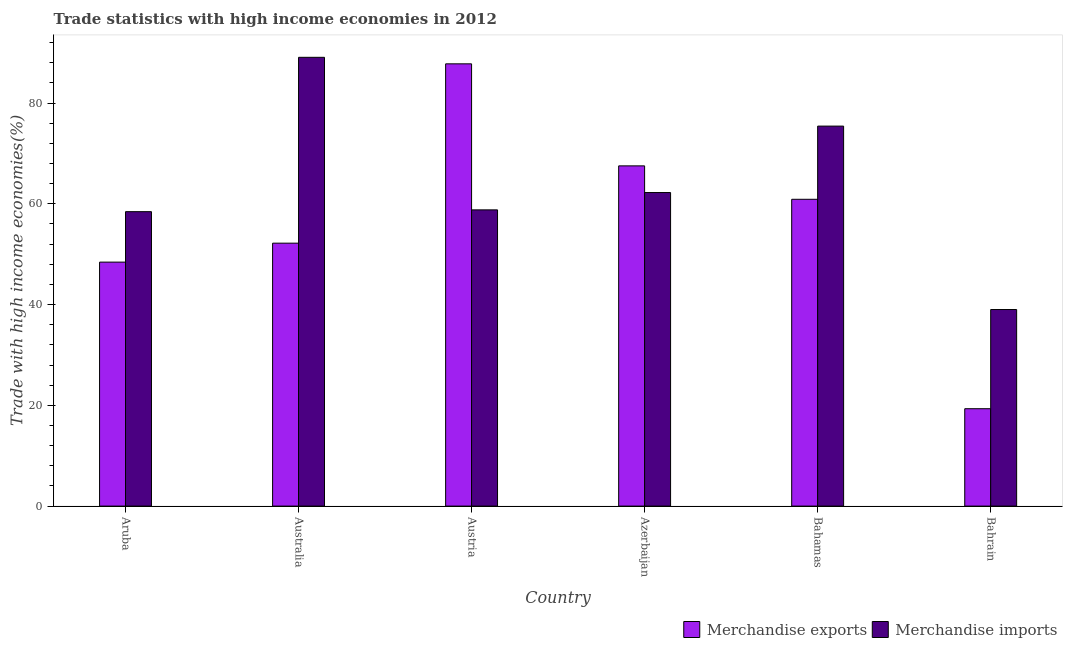Are the number of bars per tick equal to the number of legend labels?
Keep it short and to the point. Yes. How many bars are there on the 6th tick from the left?
Make the answer very short. 2. What is the label of the 6th group of bars from the left?
Your response must be concise. Bahrain. What is the merchandise imports in Aruba?
Give a very brief answer. 58.44. Across all countries, what is the maximum merchandise imports?
Give a very brief answer. 89.08. Across all countries, what is the minimum merchandise exports?
Offer a very short reply. 19.33. In which country was the merchandise exports minimum?
Offer a terse response. Bahrain. What is the total merchandise imports in the graph?
Offer a very short reply. 382.99. What is the difference between the merchandise imports in Austria and that in Bahrain?
Your answer should be very brief. 19.78. What is the difference between the merchandise exports in Australia and the merchandise imports in Bahamas?
Your answer should be compact. -23.24. What is the average merchandise imports per country?
Give a very brief answer. 63.83. What is the difference between the merchandise exports and merchandise imports in Bahrain?
Offer a very short reply. -19.69. What is the ratio of the merchandise imports in Aruba to that in Australia?
Provide a short and direct response. 0.66. Is the merchandise imports in Azerbaijan less than that in Bahrain?
Give a very brief answer. No. What is the difference between the highest and the second highest merchandise exports?
Your answer should be compact. 20.25. What is the difference between the highest and the lowest merchandise exports?
Provide a short and direct response. 68.45. Is the sum of the merchandise exports in Aruba and Australia greater than the maximum merchandise imports across all countries?
Your answer should be very brief. Yes. What does the 2nd bar from the left in Azerbaijan represents?
Provide a short and direct response. Merchandise imports. What does the 2nd bar from the right in Bahamas represents?
Offer a terse response. Merchandise exports. How many bars are there?
Ensure brevity in your answer.  12. How many countries are there in the graph?
Give a very brief answer. 6. Does the graph contain any zero values?
Offer a terse response. No. Where does the legend appear in the graph?
Your response must be concise. Bottom right. How many legend labels are there?
Your response must be concise. 2. How are the legend labels stacked?
Your answer should be very brief. Horizontal. What is the title of the graph?
Your response must be concise. Trade statistics with high income economies in 2012. Does "Technicians" appear as one of the legend labels in the graph?
Make the answer very short. No. What is the label or title of the Y-axis?
Your response must be concise. Trade with high income economies(%). What is the Trade with high income economies(%) of Merchandise exports in Aruba?
Offer a very short reply. 48.43. What is the Trade with high income economies(%) of Merchandise imports in Aruba?
Your answer should be compact. 58.44. What is the Trade with high income economies(%) in Merchandise exports in Australia?
Ensure brevity in your answer.  52.19. What is the Trade with high income economies(%) of Merchandise imports in Australia?
Your answer should be compact. 89.08. What is the Trade with high income economies(%) of Merchandise exports in Austria?
Keep it short and to the point. 87.78. What is the Trade with high income economies(%) of Merchandise imports in Austria?
Your answer should be very brief. 58.8. What is the Trade with high income economies(%) in Merchandise exports in Azerbaijan?
Give a very brief answer. 67.53. What is the Trade with high income economies(%) in Merchandise imports in Azerbaijan?
Keep it short and to the point. 62.23. What is the Trade with high income economies(%) of Merchandise exports in Bahamas?
Your response must be concise. 60.9. What is the Trade with high income economies(%) of Merchandise imports in Bahamas?
Your answer should be compact. 75.42. What is the Trade with high income economies(%) in Merchandise exports in Bahrain?
Offer a very short reply. 19.33. What is the Trade with high income economies(%) of Merchandise imports in Bahrain?
Provide a short and direct response. 39.02. Across all countries, what is the maximum Trade with high income economies(%) in Merchandise exports?
Provide a short and direct response. 87.78. Across all countries, what is the maximum Trade with high income economies(%) of Merchandise imports?
Provide a short and direct response. 89.08. Across all countries, what is the minimum Trade with high income economies(%) in Merchandise exports?
Offer a terse response. 19.33. Across all countries, what is the minimum Trade with high income economies(%) in Merchandise imports?
Make the answer very short. 39.02. What is the total Trade with high income economies(%) of Merchandise exports in the graph?
Offer a terse response. 336.15. What is the total Trade with high income economies(%) in Merchandise imports in the graph?
Give a very brief answer. 382.99. What is the difference between the Trade with high income economies(%) in Merchandise exports in Aruba and that in Australia?
Keep it short and to the point. -3.76. What is the difference between the Trade with high income economies(%) of Merchandise imports in Aruba and that in Australia?
Provide a short and direct response. -30.64. What is the difference between the Trade with high income economies(%) of Merchandise exports in Aruba and that in Austria?
Offer a very short reply. -39.35. What is the difference between the Trade with high income economies(%) in Merchandise imports in Aruba and that in Austria?
Your answer should be very brief. -0.36. What is the difference between the Trade with high income economies(%) in Merchandise exports in Aruba and that in Azerbaijan?
Offer a very short reply. -19.1. What is the difference between the Trade with high income economies(%) of Merchandise imports in Aruba and that in Azerbaijan?
Keep it short and to the point. -3.79. What is the difference between the Trade with high income economies(%) in Merchandise exports in Aruba and that in Bahamas?
Offer a terse response. -12.47. What is the difference between the Trade with high income economies(%) of Merchandise imports in Aruba and that in Bahamas?
Ensure brevity in your answer.  -16.98. What is the difference between the Trade with high income economies(%) of Merchandise exports in Aruba and that in Bahrain?
Offer a very short reply. 29.1. What is the difference between the Trade with high income economies(%) of Merchandise imports in Aruba and that in Bahrain?
Ensure brevity in your answer.  19.42. What is the difference between the Trade with high income economies(%) of Merchandise exports in Australia and that in Austria?
Offer a terse response. -35.59. What is the difference between the Trade with high income economies(%) of Merchandise imports in Australia and that in Austria?
Provide a succinct answer. 30.28. What is the difference between the Trade with high income economies(%) in Merchandise exports in Australia and that in Azerbaijan?
Your response must be concise. -15.34. What is the difference between the Trade with high income economies(%) of Merchandise imports in Australia and that in Azerbaijan?
Your response must be concise. 26.84. What is the difference between the Trade with high income economies(%) in Merchandise exports in Australia and that in Bahamas?
Provide a short and direct response. -8.71. What is the difference between the Trade with high income economies(%) of Merchandise imports in Australia and that in Bahamas?
Offer a terse response. 13.65. What is the difference between the Trade with high income economies(%) in Merchandise exports in Australia and that in Bahrain?
Ensure brevity in your answer.  32.86. What is the difference between the Trade with high income economies(%) of Merchandise imports in Australia and that in Bahrain?
Offer a very short reply. 50.06. What is the difference between the Trade with high income economies(%) of Merchandise exports in Austria and that in Azerbaijan?
Provide a short and direct response. 20.25. What is the difference between the Trade with high income economies(%) in Merchandise imports in Austria and that in Azerbaijan?
Your answer should be very brief. -3.44. What is the difference between the Trade with high income economies(%) of Merchandise exports in Austria and that in Bahamas?
Make the answer very short. 26.88. What is the difference between the Trade with high income economies(%) of Merchandise imports in Austria and that in Bahamas?
Keep it short and to the point. -16.63. What is the difference between the Trade with high income economies(%) in Merchandise exports in Austria and that in Bahrain?
Give a very brief answer. 68.45. What is the difference between the Trade with high income economies(%) of Merchandise imports in Austria and that in Bahrain?
Your answer should be compact. 19.78. What is the difference between the Trade with high income economies(%) in Merchandise exports in Azerbaijan and that in Bahamas?
Your answer should be very brief. 6.63. What is the difference between the Trade with high income economies(%) in Merchandise imports in Azerbaijan and that in Bahamas?
Offer a terse response. -13.19. What is the difference between the Trade with high income economies(%) in Merchandise exports in Azerbaijan and that in Bahrain?
Make the answer very short. 48.2. What is the difference between the Trade with high income economies(%) in Merchandise imports in Azerbaijan and that in Bahrain?
Offer a very short reply. 23.22. What is the difference between the Trade with high income economies(%) of Merchandise exports in Bahamas and that in Bahrain?
Keep it short and to the point. 41.57. What is the difference between the Trade with high income economies(%) in Merchandise imports in Bahamas and that in Bahrain?
Provide a succinct answer. 36.41. What is the difference between the Trade with high income economies(%) of Merchandise exports in Aruba and the Trade with high income economies(%) of Merchandise imports in Australia?
Your answer should be compact. -40.65. What is the difference between the Trade with high income economies(%) of Merchandise exports in Aruba and the Trade with high income economies(%) of Merchandise imports in Austria?
Provide a short and direct response. -10.37. What is the difference between the Trade with high income economies(%) of Merchandise exports in Aruba and the Trade with high income economies(%) of Merchandise imports in Azerbaijan?
Your answer should be compact. -13.81. What is the difference between the Trade with high income economies(%) in Merchandise exports in Aruba and the Trade with high income economies(%) in Merchandise imports in Bahamas?
Make the answer very short. -27. What is the difference between the Trade with high income economies(%) of Merchandise exports in Aruba and the Trade with high income economies(%) of Merchandise imports in Bahrain?
Keep it short and to the point. 9.41. What is the difference between the Trade with high income economies(%) of Merchandise exports in Australia and the Trade with high income economies(%) of Merchandise imports in Austria?
Offer a terse response. -6.61. What is the difference between the Trade with high income economies(%) of Merchandise exports in Australia and the Trade with high income economies(%) of Merchandise imports in Azerbaijan?
Your answer should be compact. -10.05. What is the difference between the Trade with high income economies(%) in Merchandise exports in Australia and the Trade with high income economies(%) in Merchandise imports in Bahamas?
Give a very brief answer. -23.24. What is the difference between the Trade with high income economies(%) of Merchandise exports in Australia and the Trade with high income economies(%) of Merchandise imports in Bahrain?
Keep it short and to the point. 13.17. What is the difference between the Trade with high income economies(%) of Merchandise exports in Austria and the Trade with high income economies(%) of Merchandise imports in Azerbaijan?
Offer a terse response. 25.55. What is the difference between the Trade with high income economies(%) of Merchandise exports in Austria and the Trade with high income economies(%) of Merchandise imports in Bahamas?
Offer a terse response. 12.36. What is the difference between the Trade with high income economies(%) in Merchandise exports in Austria and the Trade with high income economies(%) in Merchandise imports in Bahrain?
Your answer should be very brief. 48.76. What is the difference between the Trade with high income economies(%) of Merchandise exports in Azerbaijan and the Trade with high income economies(%) of Merchandise imports in Bahamas?
Make the answer very short. -7.89. What is the difference between the Trade with high income economies(%) in Merchandise exports in Azerbaijan and the Trade with high income economies(%) in Merchandise imports in Bahrain?
Your response must be concise. 28.51. What is the difference between the Trade with high income economies(%) in Merchandise exports in Bahamas and the Trade with high income economies(%) in Merchandise imports in Bahrain?
Offer a very short reply. 21.88. What is the average Trade with high income economies(%) of Merchandise exports per country?
Give a very brief answer. 56.03. What is the average Trade with high income economies(%) in Merchandise imports per country?
Keep it short and to the point. 63.83. What is the difference between the Trade with high income economies(%) in Merchandise exports and Trade with high income economies(%) in Merchandise imports in Aruba?
Provide a succinct answer. -10.01. What is the difference between the Trade with high income economies(%) of Merchandise exports and Trade with high income economies(%) of Merchandise imports in Australia?
Your answer should be very brief. -36.89. What is the difference between the Trade with high income economies(%) of Merchandise exports and Trade with high income economies(%) of Merchandise imports in Austria?
Your response must be concise. 28.98. What is the difference between the Trade with high income economies(%) of Merchandise exports and Trade with high income economies(%) of Merchandise imports in Azerbaijan?
Your response must be concise. 5.3. What is the difference between the Trade with high income economies(%) in Merchandise exports and Trade with high income economies(%) in Merchandise imports in Bahamas?
Your response must be concise. -14.53. What is the difference between the Trade with high income economies(%) of Merchandise exports and Trade with high income economies(%) of Merchandise imports in Bahrain?
Your response must be concise. -19.69. What is the ratio of the Trade with high income economies(%) in Merchandise exports in Aruba to that in Australia?
Provide a short and direct response. 0.93. What is the ratio of the Trade with high income economies(%) of Merchandise imports in Aruba to that in Australia?
Your answer should be compact. 0.66. What is the ratio of the Trade with high income economies(%) of Merchandise exports in Aruba to that in Austria?
Provide a short and direct response. 0.55. What is the ratio of the Trade with high income economies(%) in Merchandise exports in Aruba to that in Azerbaijan?
Make the answer very short. 0.72. What is the ratio of the Trade with high income economies(%) in Merchandise imports in Aruba to that in Azerbaijan?
Your answer should be very brief. 0.94. What is the ratio of the Trade with high income economies(%) in Merchandise exports in Aruba to that in Bahamas?
Keep it short and to the point. 0.8. What is the ratio of the Trade with high income economies(%) in Merchandise imports in Aruba to that in Bahamas?
Give a very brief answer. 0.77. What is the ratio of the Trade with high income economies(%) in Merchandise exports in Aruba to that in Bahrain?
Your answer should be very brief. 2.51. What is the ratio of the Trade with high income economies(%) in Merchandise imports in Aruba to that in Bahrain?
Give a very brief answer. 1.5. What is the ratio of the Trade with high income economies(%) in Merchandise exports in Australia to that in Austria?
Your response must be concise. 0.59. What is the ratio of the Trade with high income economies(%) in Merchandise imports in Australia to that in Austria?
Your response must be concise. 1.51. What is the ratio of the Trade with high income economies(%) of Merchandise exports in Australia to that in Azerbaijan?
Provide a succinct answer. 0.77. What is the ratio of the Trade with high income economies(%) in Merchandise imports in Australia to that in Azerbaijan?
Provide a succinct answer. 1.43. What is the ratio of the Trade with high income economies(%) of Merchandise exports in Australia to that in Bahamas?
Offer a very short reply. 0.86. What is the ratio of the Trade with high income economies(%) in Merchandise imports in Australia to that in Bahamas?
Provide a succinct answer. 1.18. What is the ratio of the Trade with high income economies(%) in Merchandise exports in Australia to that in Bahrain?
Ensure brevity in your answer.  2.7. What is the ratio of the Trade with high income economies(%) in Merchandise imports in Australia to that in Bahrain?
Offer a very short reply. 2.28. What is the ratio of the Trade with high income economies(%) in Merchandise exports in Austria to that in Azerbaijan?
Offer a very short reply. 1.3. What is the ratio of the Trade with high income economies(%) in Merchandise imports in Austria to that in Azerbaijan?
Ensure brevity in your answer.  0.94. What is the ratio of the Trade with high income economies(%) in Merchandise exports in Austria to that in Bahamas?
Keep it short and to the point. 1.44. What is the ratio of the Trade with high income economies(%) of Merchandise imports in Austria to that in Bahamas?
Keep it short and to the point. 0.78. What is the ratio of the Trade with high income economies(%) of Merchandise exports in Austria to that in Bahrain?
Provide a short and direct response. 4.54. What is the ratio of the Trade with high income economies(%) in Merchandise imports in Austria to that in Bahrain?
Provide a succinct answer. 1.51. What is the ratio of the Trade with high income economies(%) of Merchandise exports in Azerbaijan to that in Bahamas?
Your response must be concise. 1.11. What is the ratio of the Trade with high income economies(%) of Merchandise imports in Azerbaijan to that in Bahamas?
Give a very brief answer. 0.83. What is the ratio of the Trade with high income economies(%) of Merchandise exports in Azerbaijan to that in Bahrain?
Offer a very short reply. 3.49. What is the ratio of the Trade with high income economies(%) in Merchandise imports in Azerbaijan to that in Bahrain?
Your answer should be very brief. 1.59. What is the ratio of the Trade with high income economies(%) of Merchandise exports in Bahamas to that in Bahrain?
Offer a terse response. 3.15. What is the ratio of the Trade with high income economies(%) of Merchandise imports in Bahamas to that in Bahrain?
Your answer should be compact. 1.93. What is the difference between the highest and the second highest Trade with high income economies(%) of Merchandise exports?
Make the answer very short. 20.25. What is the difference between the highest and the second highest Trade with high income economies(%) in Merchandise imports?
Provide a succinct answer. 13.65. What is the difference between the highest and the lowest Trade with high income economies(%) in Merchandise exports?
Offer a terse response. 68.45. What is the difference between the highest and the lowest Trade with high income economies(%) of Merchandise imports?
Your response must be concise. 50.06. 